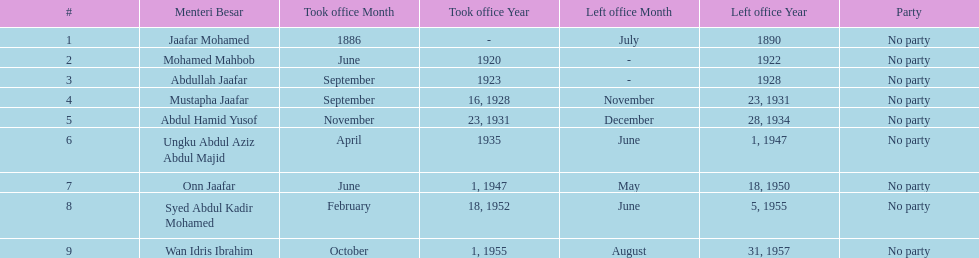Who took office after onn jaafar? Syed Abdul Kadir Mohamed. 